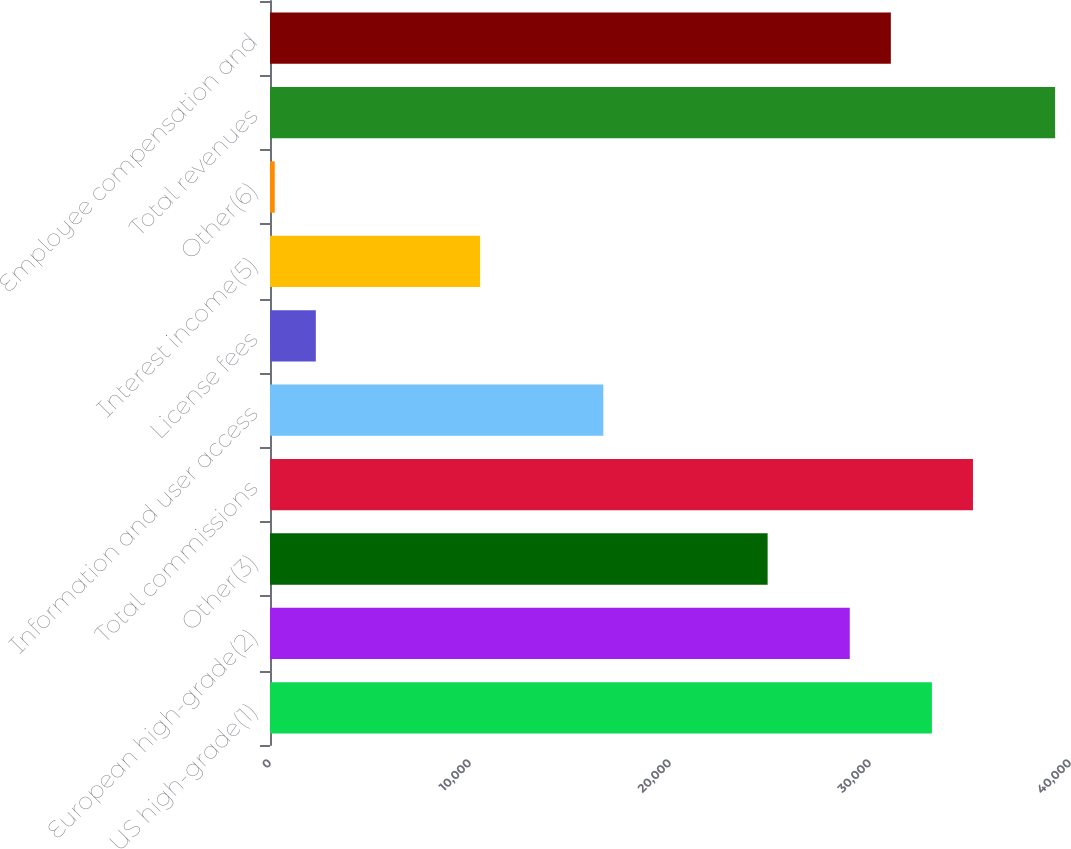<chart> <loc_0><loc_0><loc_500><loc_500><bar_chart><fcel>US high-grade(1)<fcel>European high-grade(2)<fcel>Other(3)<fcel>Total commissions<fcel>Information and user access<fcel>License fees<fcel>Interest income(5)<fcel>Other(6)<fcel>Total revenues<fcel>Employee compensation and<nl><fcel>33095.6<fcel>28988.4<fcel>24881.2<fcel>35149.2<fcel>16666.8<fcel>2291.6<fcel>10506<fcel>238<fcel>39256.4<fcel>31042<nl></chart> 